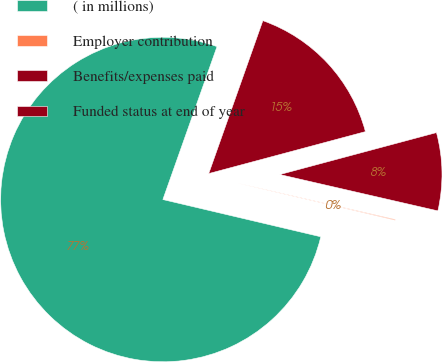<chart> <loc_0><loc_0><loc_500><loc_500><pie_chart><fcel>( in millions)<fcel>Employer contribution<fcel>Benefits/expenses paid<fcel>Funded status at end of year<nl><fcel>76.73%<fcel>0.09%<fcel>7.76%<fcel>15.42%<nl></chart> 